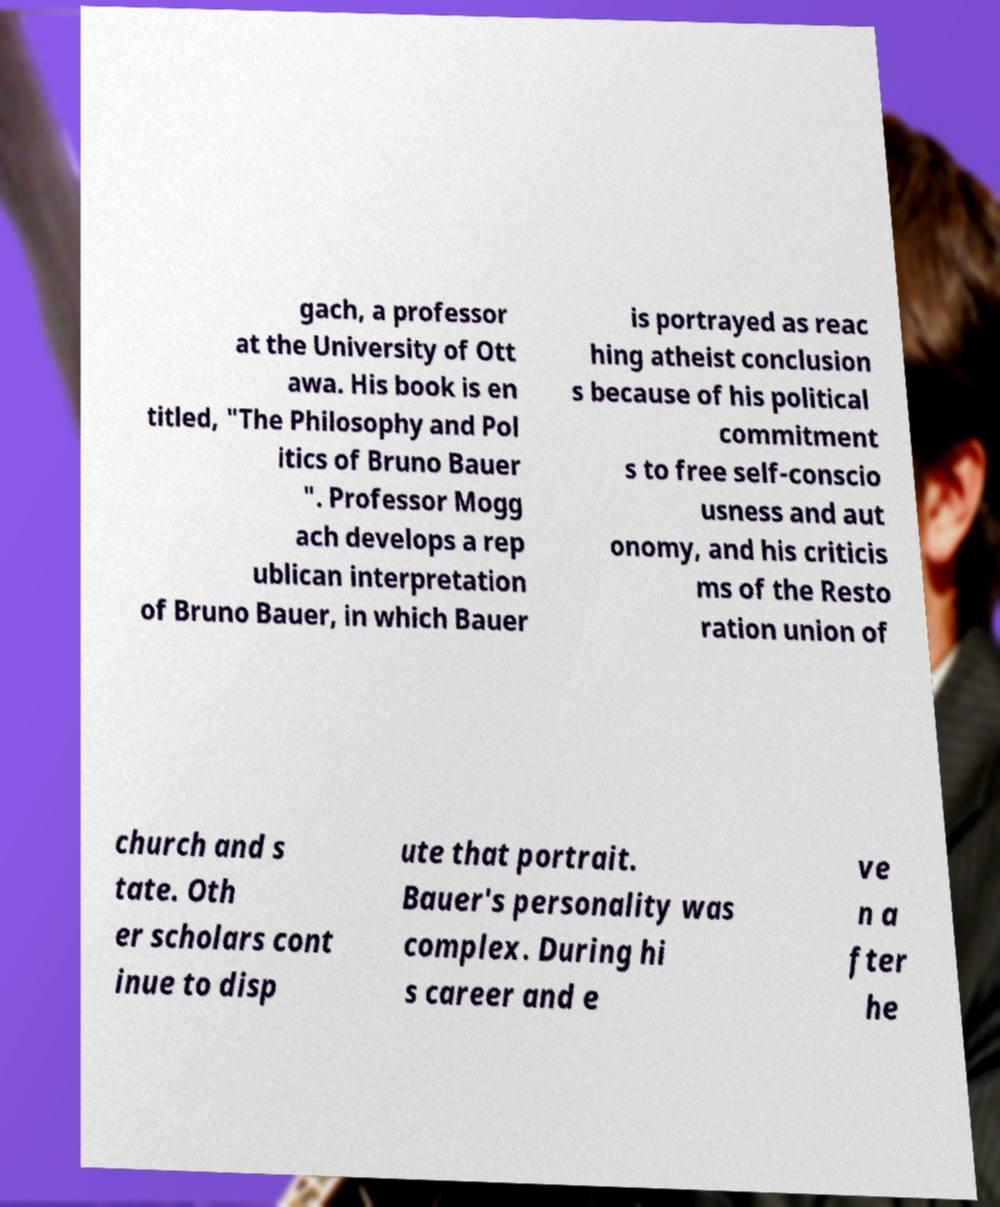Can you read and provide the text displayed in the image?This photo seems to have some interesting text. Can you extract and type it out for me? gach, a professor at the University of Ott awa. His book is en titled, "The Philosophy and Pol itics of Bruno Bauer ". Professor Mogg ach develops a rep ublican interpretation of Bruno Bauer, in which Bauer is portrayed as reac hing atheist conclusion s because of his political commitment s to free self-conscio usness and aut onomy, and his criticis ms of the Resto ration union of church and s tate. Oth er scholars cont inue to disp ute that portrait. Bauer's personality was complex. During hi s career and e ve n a fter he 